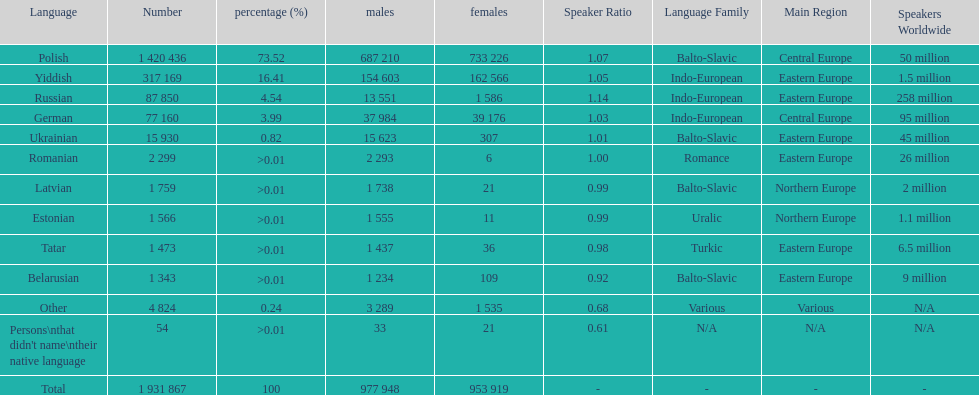Which language had the smallest number of females speaking it. Romanian. 